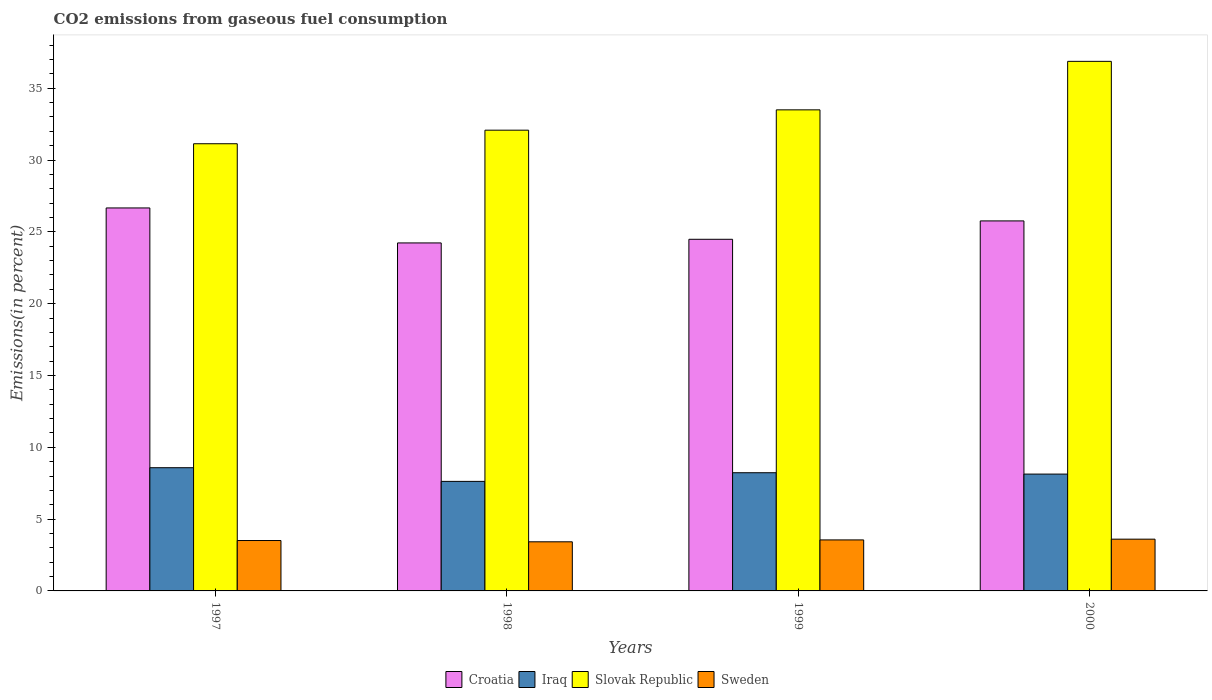Are the number of bars per tick equal to the number of legend labels?
Provide a succinct answer. Yes. How many bars are there on the 4th tick from the right?
Offer a very short reply. 4. What is the label of the 1st group of bars from the left?
Make the answer very short. 1997. What is the total CO2 emitted in Sweden in 1998?
Provide a succinct answer. 3.42. Across all years, what is the maximum total CO2 emitted in Slovak Republic?
Your response must be concise. 36.87. Across all years, what is the minimum total CO2 emitted in Slovak Republic?
Provide a succinct answer. 31.13. In which year was the total CO2 emitted in Slovak Republic maximum?
Your answer should be compact. 2000. In which year was the total CO2 emitted in Sweden minimum?
Your answer should be compact. 1998. What is the total total CO2 emitted in Iraq in the graph?
Make the answer very short. 32.57. What is the difference between the total CO2 emitted in Sweden in 1997 and that in 1998?
Provide a succinct answer. 0.09. What is the difference between the total CO2 emitted in Slovak Republic in 2000 and the total CO2 emitted in Iraq in 1998?
Offer a very short reply. 29.24. What is the average total CO2 emitted in Sweden per year?
Your response must be concise. 3.52. In the year 2000, what is the difference between the total CO2 emitted in Iraq and total CO2 emitted in Slovak Republic?
Provide a succinct answer. -28.73. In how many years, is the total CO2 emitted in Slovak Republic greater than 16 %?
Ensure brevity in your answer.  4. What is the ratio of the total CO2 emitted in Slovak Republic in 1997 to that in 1998?
Offer a very short reply. 0.97. Is the difference between the total CO2 emitted in Iraq in 1997 and 1999 greater than the difference between the total CO2 emitted in Slovak Republic in 1997 and 1999?
Ensure brevity in your answer.  Yes. What is the difference between the highest and the second highest total CO2 emitted in Iraq?
Provide a succinct answer. 0.35. What is the difference between the highest and the lowest total CO2 emitted in Slovak Republic?
Provide a short and direct response. 5.74. In how many years, is the total CO2 emitted in Sweden greater than the average total CO2 emitted in Sweden taken over all years?
Ensure brevity in your answer.  2. Is it the case that in every year, the sum of the total CO2 emitted in Croatia and total CO2 emitted in Sweden is greater than the sum of total CO2 emitted in Iraq and total CO2 emitted in Slovak Republic?
Provide a short and direct response. No. What does the 3rd bar from the left in 2000 represents?
Make the answer very short. Slovak Republic. What does the 3rd bar from the right in 1998 represents?
Give a very brief answer. Iraq. Is it the case that in every year, the sum of the total CO2 emitted in Sweden and total CO2 emitted in Croatia is greater than the total CO2 emitted in Iraq?
Provide a short and direct response. Yes. How many bars are there?
Provide a succinct answer. 16. Are all the bars in the graph horizontal?
Your response must be concise. No. Are the values on the major ticks of Y-axis written in scientific E-notation?
Your answer should be very brief. No. Does the graph contain any zero values?
Offer a very short reply. No. Does the graph contain grids?
Provide a succinct answer. No. How many legend labels are there?
Offer a terse response. 4. What is the title of the graph?
Make the answer very short. CO2 emissions from gaseous fuel consumption. Does "Comoros" appear as one of the legend labels in the graph?
Offer a terse response. No. What is the label or title of the X-axis?
Make the answer very short. Years. What is the label or title of the Y-axis?
Make the answer very short. Emissions(in percent). What is the Emissions(in percent) of Croatia in 1997?
Your answer should be very brief. 26.66. What is the Emissions(in percent) of Iraq in 1997?
Offer a very short reply. 8.58. What is the Emissions(in percent) in Slovak Republic in 1997?
Offer a terse response. 31.13. What is the Emissions(in percent) of Sweden in 1997?
Give a very brief answer. 3.51. What is the Emissions(in percent) in Croatia in 1998?
Ensure brevity in your answer.  24.23. What is the Emissions(in percent) of Iraq in 1998?
Keep it short and to the point. 7.63. What is the Emissions(in percent) of Slovak Republic in 1998?
Provide a succinct answer. 32.08. What is the Emissions(in percent) of Sweden in 1998?
Make the answer very short. 3.42. What is the Emissions(in percent) of Croatia in 1999?
Ensure brevity in your answer.  24.48. What is the Emissions(in percent) of Iraq in 1999?
Offer a very short reply. 8.23. What is the Emissions(in percent) in Slovak Republic in 1999?
Offer a very short reply. 33.49. What is the Emissions(in percent) in Sweden in 1999?
Offer a very short reply. 3.55. What is the Emissions(in percent) in Croatia in 2000?
Your answer should be very brief. 25.76. What is the Emissions(in percent) in Iraq in 2000?
Offer a terse response. 8.13. What is the Emissions(in percent) in Slovak Republic in 2000?
Your response must be concise. 36.87. What is the Emissions(in percent) of Sweden in 2000?
Make the answer very short. 3.6. Across all years, what is the maximum Emissions(in percent) of Croatia?
Provide a succinct answer. 26.66. Across all years, what is the maximum Emissions(in percent) of Iraq?
Provide a short and direct response. 8.58. Across all years, what is the maximum Emissions(in percent) of Slovak Republic?
Ensure brevity in your answer.  36.87. Across all years, what is the maximum Emissions(in percent) of Sweden?
Keep it short and to the point. 3.6. Across all years, what is the minimum Emissions(in percent) of Croatia?
Keep it short and to the point. 24.23. Across all years, what is the minimum Emissions(in percent) of Iraq?
Your answer should be compact. 7.63. Across all years, what is the minimum Emissions(in percent) of Slovak Republic?
Offer a terse response. 31.13. Across all years, what is the minimum Emissions(in percent) of Sweden?
Offer a very short reply. 3.42. What is the total Emissions(in percent) in Croatia in the graph?
Make the answer very short. 101.13. What is the total Emissions(in percent) in Iraq in the graph?
Your answer should be very brief. 32.57. What is the total Emissions(in percent) of Slovak Republic in the graph?
Provide a short and direct response. 133.57. What is the total Emissions(in percent) of Sweden in the graph?
Your answer should be compact. 14.08. What is the difference between the Emissions(in percent) in Croatia in 1997 and that in 1998?
Your answer should be very brief. 2.44. What is the difference between the Emissions(in percent) of Iraq in 1997 and that in 1998?
Your response must be concise. 0.95. What is the difference between the Emissions(in percent) of Slovak Republic in 1997 and that in 1998?
Your response must be concise. -0.94. What is the difference between the Emissions(in percent) in Sweden in 1997 and that in 1998?
Ensure brevity in your answer.  0.09. What is the difference between the Emissions(in percent) in Croatia in 1997 and that in 1999?
Keep it short and to the point. 2.18. What is the difference between the Emissions(in percent) in Iraq in 1997 and that in 1999?
Give a very brief answer. 0.35. What is the difference between the Emissions(in percent) in Slovak Republic in 1997 and that in 1999?
Your response must be concise. -2.36. What is the difference between the Emissions(in percent) in Sweden in 1997 and that in 1999?
Provide a short and direct response. -0.04. What is the difference between the Emissions(in percent) in Croatia in 1997 and that in 2000?
Give a very brief answer. 0.9. What is the difference between the Emissions(in percent) of Iraq in 1997 and that in 2000?
Ensure brevity in your answer.  0.44. What is the difference between the Emissions(in percent) in Slovak Republic in 1997 and that in 2000?
Your response must be concise. -5.74. What is the difference between the Emissions(in percent) in Sweden in 1997 and that in 2000?
Your answer should be compact. -0.09. What is the difference between the Emissions(in percent) of Croatia in 1998 and that in 1999?
Your answer should be compact. -0.25. What is the difference between the Emissions(in percent) of Iraq in 1998 and that in 1999?
Provide a succinct answer. -0.6. What is the difference between the Emissions(in percent) of Slovak Republic in 1998 and that in 1999?
Your answer should be very brief. -1.42. What is the difference between the Emissions(in percent) in Sweden in 1998 and that in 1999?
Provide a succinct answer. -0.13. What is the difference between the Emissions(in percent) of Croatia in 1998 and that in 2000?
Provide a succinct answer. -1.53. What is the difference between the Emissions(in percent) of Iraq in 1998 and that in 2000?
Provide a succinct answer. -0.51. What is the difference between the Emissions(in percent) in Slovak Republic in 1998 and that in 2000?
Provide a short and direct response. -4.79. What is the difference between the Emissions(in percent) in Sweden in 1998 and that in 2000?
Keep it short and to the point. -0.18. What is the difference between the Emissions(in percent) in Croatia in 1999 and that in 2000?
Your response must be concise. -1.28. What is the difference between the Emissions(in percent) of Iraq in 1999 and that in 2000?
Offer a very short reply. 0.09. What is the difference between the Emissions(in percent) of Slovak Republic in 1999 and that in 2000?
Offer a very short reply. -3.38. What is the difference between the Emissions(in percent) in Sweden in 1999 and that in 2000?
Your response must be concise. -0.05. What is the difference between the Emissions(in percent) of Croatia in 1997 and the Emissions(in percent) of Iraq in 1998?
Ensure brevity in your answer.  19.04. What is the difference between the Emissions(in percent) of Croatia in 1997 and the Emissions(in percent) of Slovak Republic in 1998?
Offer a terse response. -5.41. What is the difference between the Emissions(in percent) of Croatia in 1997 and the Emissions(in percent) of Sweden in 1998?
Offer a terse response. 23.24. What is the difference between the Emissions(in percent) in Iraq in 1997 and the Emissions(in percent) in Slovak Republic in 1998?
Keep it short and to the point. -23.5. What is the difference between the Emissions(in percent) in Iraq in 1997 and the Emissions(in percent) in Sweden in 1998?
Offer a very short reply. 5.16. What is the difference between the Emissions(in percent) in Slovak Republic in 1997 and the Emissions(in percent) in Sweden in 1998?
Offer a very short reply. 27.71. What is the difference between the Emissions(in percent) in Croatia in 1997 and the Emissions(in percent) in Iraq in 1999?
Offer a very short reply. 18.43. What is the difference between the Emissions(in percent) of Croatia in 1997 and the Emissions(in percent) of Slovak Republic in 1999?
Offer a very short reply. -6.83. What is the difference between the Emissions(in percent) of Croatia in 1997 and the Emissions(in percent) of Sweden in 1999?
Keep it short and to the point. 23.11. What is the difference between the Emissions(in percent) in Iraq in 1997 and the Emissions(in percent) in Slovak Republic in 1999?
Offer a very short reply. -24.91. What is the difference between the Emissions(in percent) in Iraq in 1997 and the Emissions(in percent) in Sweden in 1999?
Ensure brevity in your answer.  5.03. What is the difference between the Emissions(in percent) of Slovak Republic in 1997 and the Emissions(in percent) of Sweden in 1999?
Your response must be concise. 27.58. What is the difference between the Emissions(in percent) of Croatia in 1997 and the Emissions(in percent) of Iraq in 2000?
Keep it short and to the point. 18.53. What is the difference between the Emissions(in percent) of Croatia in 1997 and the Emissions(in percent) of Slovak Republic in 2000?
Give a very brief answer. -10.21. What is the difference between the Emissions(in percent) of Croatia in 1997 and the Emissions(in percent) of Sweden in 2000?
Provide a short and direct response. 23.06. What is the difference between the Emissions(in percent) of Iraq in 1997 and the Emissions(in percent) of Slovak Republic in 2000?
Make the answer very short. -28.29. What is the difference between the Emissions(in percent) in Iraq in 1997 and the Emissions(in percent) in Sweden in 2000?
Keep it short and to the point. 4.97. What is the difference between the Emissions(in percent) in Slovak Republic in 1997 and the Emissions(in percent) in Sweden in 2000?
Make the answer very short. 27.53. What is the difference between the Emissions(in percent) in Croatia in 1998 and the Emissions(in percent) in Iraq in 1999?
Ensure brevity in your answer.  16. What is the difference between the Emissions(in percent) in Croatia in 1998 and the Emissions(in percent) in Slovak Republic in 1999?
Provide a short and direct response. -9.26. What is the difference between the Emissions(in percent) of Croatia in 1998 and the Emissions(in percent) of Sweden in 1999?
Keep it short and to the point. 20.68. What is the difference between the Emissions(in percent) of Iraq in 1998 and the Emissions(in percent) of Slovak Republic in 1999?
Offer a very short reply. -25.87. What is the difference between the Emissions(in percent) of Iraq in 1998 and the Emissions(in percent) of Sweden in 1999?
Offer a very short reply. 4.07. What is the difference between the Emissions(in percent) of Slovak Republic in 1998 and the Emissions(in percent) of Sweden in 1999?
Keep it short and to the point. 28.53. What is the difference between the Emissions(in percent) of Croatia in 1998 and the Emissions(in percent) of Iraq in 2000?
Provide a succinct answer. 16.09. What is the difference between the Emissions(in percent) of Croatia in 1998 and the Emissions(in percent) of Slovak Republic in 2000?
Give a very brief answer. -12.64. What is the difference between the Emissions(in percent) in Croatia in 1998 and the Emissions(in percent) in Sweden in 2000?
Your answer should be very brief. 20.62. What is the difference between the Emissions(in percent) in Iraq in 1998 and the Emissions(in percent) in Slovak Republic in 2000?
Ensure brevity in your answer.  -29.24. What is the difference between the Emissions(in percent) of Iraq in 1998 and the Emissions(in percent) of Sweden in 2000?
Offer a terse response. 4.02. What is the difference between the Emissions(in percent) of Slovak Republic in 1998 and the Emissions(in percent) of Sweden in 2000?
Make the answer very short. 28.47. What is the difference between the Emissions(in percent) of Croatia in 1999 and the Emissions(in percent) of Iraq in 2000?
Provide a succinct answer. 16.35. What is the difference between the Emissions(in percent) of Croatia in 1999 and the Emissions(in percent) of Slovak Republic in 2000?
Your answer should be very brief. -12.39. What is the difference between the Emissions(in percent) in Croatia in 1999 and the Emissions(in percent) in Sweden in 2000?
Provide a succinct answer. 20.88. What is the difference between the Emissions(in percent) of Iraq in 1999 and the Emissions(in percent) of Slovak Republic in 2000?
Your answer should be very brief. -28.64. What is the difference between the Emissions(in percent) of Iraq in 1999 and the Emissions(in percent) of Sweden in 2000?
Your answer should be very brief. 4.62. What is the difference between the Emissions(in percent) of Slovak Republic in 1999 and the Emissions(in percent) of Sweden in 2000?
Provide a short and direct response. 29.89. What is the average Emissions(in percent) in Croatia per year?
Your answer should be compact. 25.28. What is the average Emissions(in percent) in Iraq per year?
Provide a short and direct response. 8.14. What is the average Emissions(in percent) of Slovak Republic per year?
Your answer should be very brief. 33.39. What is the average Emissions(in percent) of Sweden per year?
Your answer should be very brief. 3.52. In the year 1997, what is the difference between the Emissions(in percent) in Croatia and Emissions(in percent) in Iraq?
Your answer should be very brief. 18.08. In the year 1997, what is the difference between the Emissions(in percent) of Croatia and Emissions(in percent) of Slovak Republic?
Ensure brevity in your answer.  -4.47. In the year 1997, what is the difference between the Emissions(in percent) in Croatia and Emissions(in percent) in Sweden?
Offer a very short reply. 23.15. In the year 1997, what is the difference between the Emissions(in percent) of Iraq and Emissions(in percent) of Slovak Republic?
Ensure brevity in your answer.  -22.55. In the year 1997, what is the difference between the Emissions(in percent) in Iraq and Emissions(in percent) in Sweden?
Your response must be concise. 5.07. In the year 1997, what is the difference between the Emissions(in percent) of Slovak Republic and Emissions(in percent) of Sweden?
Provide a succinct answer. 27.62. In the year 1998, what is the difference between the Emissions(in percent) of Croatia and Emissions(in percent) of Iraq?
Provide a succinct answer. 16.6. In the year 1998, what is the difference between the Emissions(in percent) of Croatia and Emissions(in percent) of Slovak Republic?
Your answer should be very brief. -7.85. In the year 1998, what is the difference between the Emissions(in percent) of Croatia and Emissions(in percent) of Sweden?
Your response must be concise. 20.81. In the year 1998, what is the difference between the Emissions(in percent) of Iraq and Emissions(in percent) of Slovak Republic?
Your answer should be very brief. -24.45. In the year 1998, what is the difference between the Emissions(in percent) in Iraq and Emissions(in percent) in Sweden?
Make the answer very short. 4.21. In the year 1998, what is the difference between the Emissions(in percent) in Slovak Republic and Emissions(in percent) in Sweden?
Your answer should be very brief. 28.66. In the year 1999, what is the difference between the Emissions(in percent) of Croatia and Emissions(in percent) of Iraq?
Keep it short and to the point. 16.25. In the year 1999, what is the difference between the Emissions(in percent) in Croatia and Emissions(in percent) in Slovak Republic?
Give a very brief answer. -9.01. In the year 1999, what is the difference between the Emissions(in percent) in Croatia and Emissions(in percent) in Sweden?
Keep it short and to the point. 20.93. In the year 1999, what is the difference between the Emissions(in percent) in Iraq and Emissions(in percent) in Slovak Republic?
Give a very brief answer. -25.26. In the year 1999, what is the difference between the Emissions(in percent) in Iraq and Emissions(in percent) in Sweden?
Offer a terse response. 4.68. In the year 1999, what is the difference between the Emissions(in percent) in Slovak Republic and Emissions(in percent) in Sweden?
Keep it short and to the point. 29.94. In the year 2000, what is the difference between the Emissions(in percent) in Croatia and Emissions(in percent) in Iraq?
Make the answer very short. 17.63. In the year 2000, what is the difference between the Emissions(in percent) in Croatia and Emissions(in percent) in Slovak Republic?
Your response must be concise. -11.11. In the year 2000, what is the difference between the Emissions(in percent) in Croatia and Emissions(in percent) in Sweden?
Provide a succinct answer. 22.16. In the year 2000, what is the difference between the Emissions(in percent) in Iraq and Emissions(in percent) in Slovak Republic?
Provide a succinct answer. -28.73. In the year 2000, what is the difference between the Emissions(in percent) in Iraq and Emissions(in percent) in Sweden?
Your answer should be very brief. 4.53. In the year 2000, what is the difference between the Emissions(in percent) of Slovak Republic and Emissions(in percent) of Sweden?
Make the answer very short. 33.27. What is the ratio of the Emissions(in percent) in Croatia in 1997 to that in 1998?
Offer a very short reply. 1.1. What is the ratio of the Emissions(in percent) in Iraq in 1997 to that in 1998?
Ensure brevity in your answer.  1.12. What is the ratio of the Emissions(in percent) in Slovak Republic in 1997 to that in 1998?
Ensure brevity in your answer.  0.97. What is the ratio of the Emissions(in percent) in Sweden in 1997 to that in 1998?
Offer a terse response. 1.03. What is the ratio of the Emissions(in percent) of Croatia in 1997 to that in 1999?
Offer a very short reply. 1.09. What is the ratio of the Emissions(in percent) of Iraq in 1997 to that in 1999?
Make the answer very short. 1.04. What is the ratio of the Emissions(in percent) of Slovak Republic in 1997 to that in 1999?
Your answer should be compact. 0.93. What is the ratio of the Emissions(in percent) of Sweden in 1997 to that in 1999?
Make the answer very short. 0.99. What is the ratio of the Emissions(in percent) of Croatia in 1997 to that in 2000?
Your answer should be very brief. 1.03. What is the ratio of the Emissions(in percent) of Iraq in 1997 to that in 2000?
Ensure brevity in your answer.  1.05. What is the ratio of the Emissions(in percent) in Slovak Republic in 1997 to that in 2000?
Offer a terse response. 0.84. What is the ratio of the Emissions(in percent) of Sweden in 1997 to that in 2000?
Ensure brevity in your answer.  0.97. What is the ratio of the Emissions(in percent) in Croatia in 1998 to that in 1999?
Offer a very short reply. 0.99. What is the ratio of the Emissions(in percent) in Iraq in 1998 to that in 1999?
Keep it short and to the point. 0.93. What is the ratio of the Emissions(in percent) of Slovak Republic in 1998 to that in 1999?
Provide a succinct answer. 0.96. What is the ratio of the Emissions(in percent) of Sweden in 1998 to that in 1999?
Provide a succinct answer. 0.96. What is the ratio of the Emissions(in percent) in Croatia in 1998 to that in 2000?
Your answer should be compact. 0.94. What is the ratio of the Emissions(in percent) in Slovak Republic in 1998 to that in 2000?
Provide a short and direct response. 0.87. What is the ratio of the Emissions(in percent) of Sweden in 1998 to that in 2000?
Offer a terse response. 0.95. What is the ratio of the Emissions(in percent) in Croatia in 1999 to that in 2000?
Provide a short and direct response. 0.95. What is the ratio of the Emissions(in percent) in Iraq in 1999 to that in 2000?
Give a very brief answer. 1.01. What is the ratio of the Emissions(in percent) in Slovak Republic in 1999 to that in 2000?
Provide a short and direct response. 0.91. What is the ratio of the Emissions(in percent) in Sweden in 1999 to that in 2000?
Give a very brief answer. 0.99. What is the difference between the highest and the second highest Emissions(in percent) in Croatia?
Your response must be concise. 0.9. What is the difference between the highest and the second highest Emissions(in percent) of Slovak Republic?
Provide a succinct answer. 3.38. What is the difference between the highest and the second highest Emissions(in percent) of Sweden?
Ensure brevity in your answer.  0.05. What is the difference between the highest and the lowest Emissions(in percent) in Croatia?
Provide a short and direct response. 2.44. What is the difference between the highest and the lowest Emissions(in percent) in Iraq?
Your answer should be compact. 0.95. What is the difference between the highest and the lowest Emissions(in percent) of Slovak Republic?
Keep it short and to the point. 5.74. What is the difference between the highest and the lowest Emissions(in percent) in Sweden?
Provide a short and direct response. 0.18. 